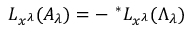<formula> <loc_0><loc_0><loc_500><loc_500>L _ { x ^ { \lambda } } ( A _ { \lambda } ) = - \ ^ { * } L _ { x ^ { \lambda } } ( \Lambda _ { \lambda } )</formula> 